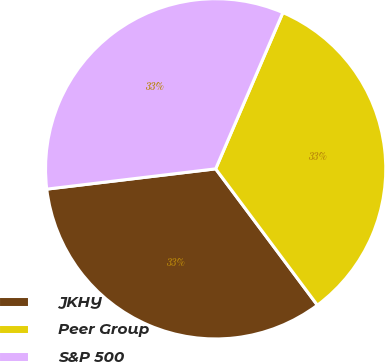Convert chart. <chart><loc_0><loc_0><loc_500><loc_500><pie_chart><fcel>JKHY<fcel>Peer Group<fcel>S&P 500<nl><fcel>33.3%<fcel>33.33%<fcel>33.37%<nl></chart> 